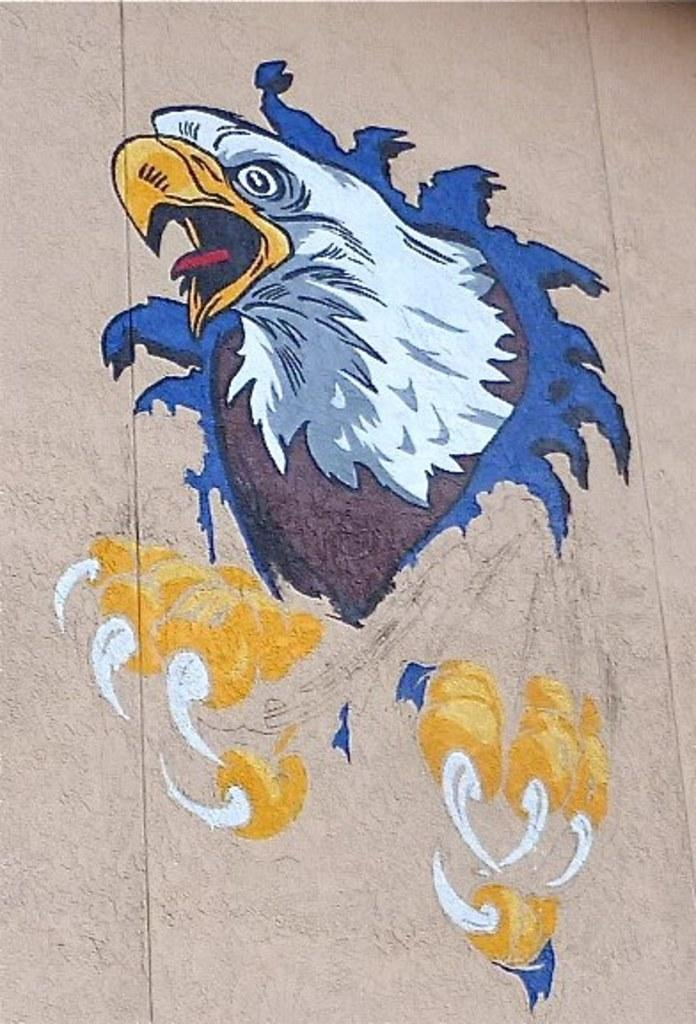What is the main subject of the image? There is a painting in the image. What is the painting placed on? The painting is on a cream-colored surface. What is depicted in the painting? The painting depicts an eagle. What colors are used in the painting of the eagle? The eagle has colors of white, yellow, red, brown, and blue. What type of curtain is hanging from the top of the painting? There is no curtain present in the image; it only features a painting of an eagle. What sound does the eagle make in the painting? The image is a still painting, so there is no sound or audible representation of the eagle's call. 